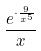<formula> <loc_0><loc_0><loc_500><loc_500>\frac { e ^ { \cdot \frac { 9 } { x ^ { 5 } } } } { x }</formula> 